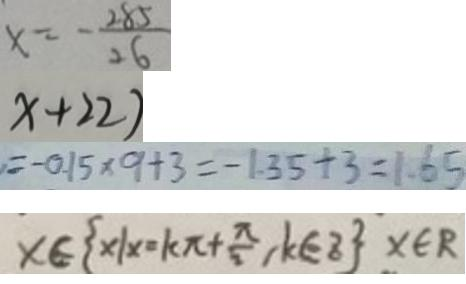<formula> <loc_0><loc_0><loc_500><loc_500>x = - \frac { 2 8 5 } { 2 6 } 
 x + 2 2 ) 
 = - 0 . 1 5 \times 9 + 3 = - 1 . 3 5 + 3 = 1 . 6 5 
 x \in \{ x \vert x \cdot k \pi + \frac { \pi } { 2 } , k \in z \} x \in R</formula> 